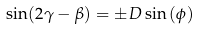Convert formula to latex. <formula><loc_0><loc_0><loc_500><loc_500>\sin ( 2 \gamma - \beta ) = \pm D \sin \left ( \phi \right )</formula> 